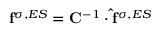Convert formula to latex. <formula><loc_0><loc_0><loc_500><loc_500>f ^ { \sigma , E S } = C ^ { - 1 } \cdot \hat { f } ^ { \sigma , E S }</formula> 